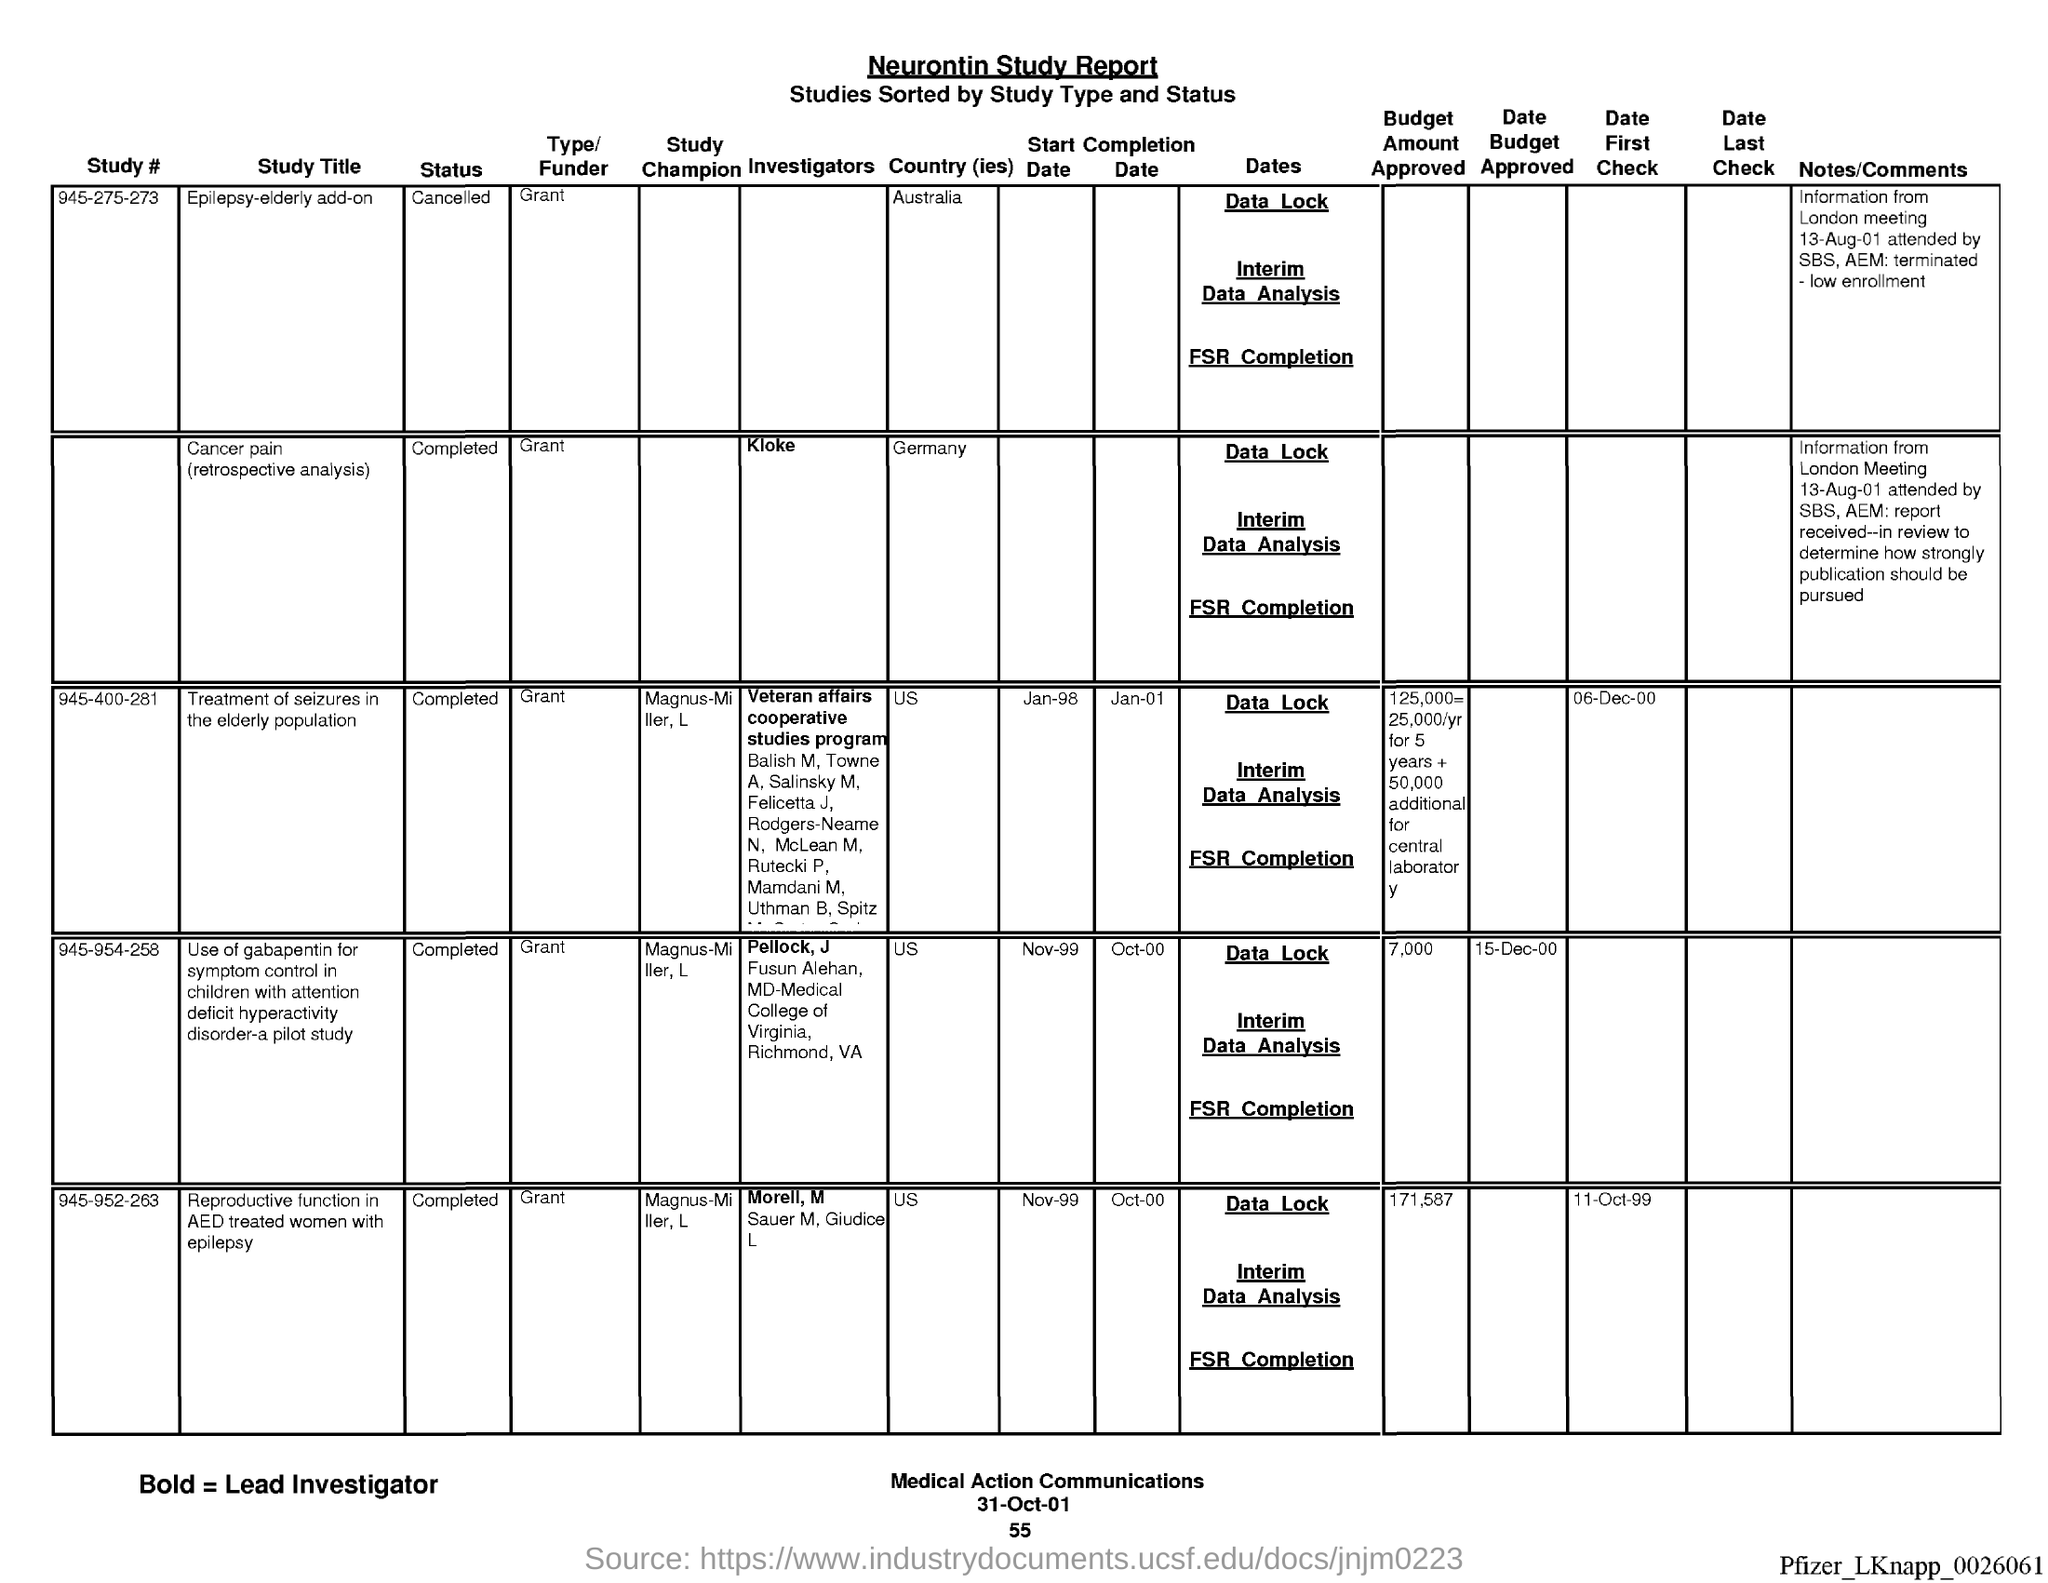Give some essential details in this illustration. The name of the report is the Neurontin study report. On the page number below the date of 55... The date at the bottom of the page is 31 October 2001. 